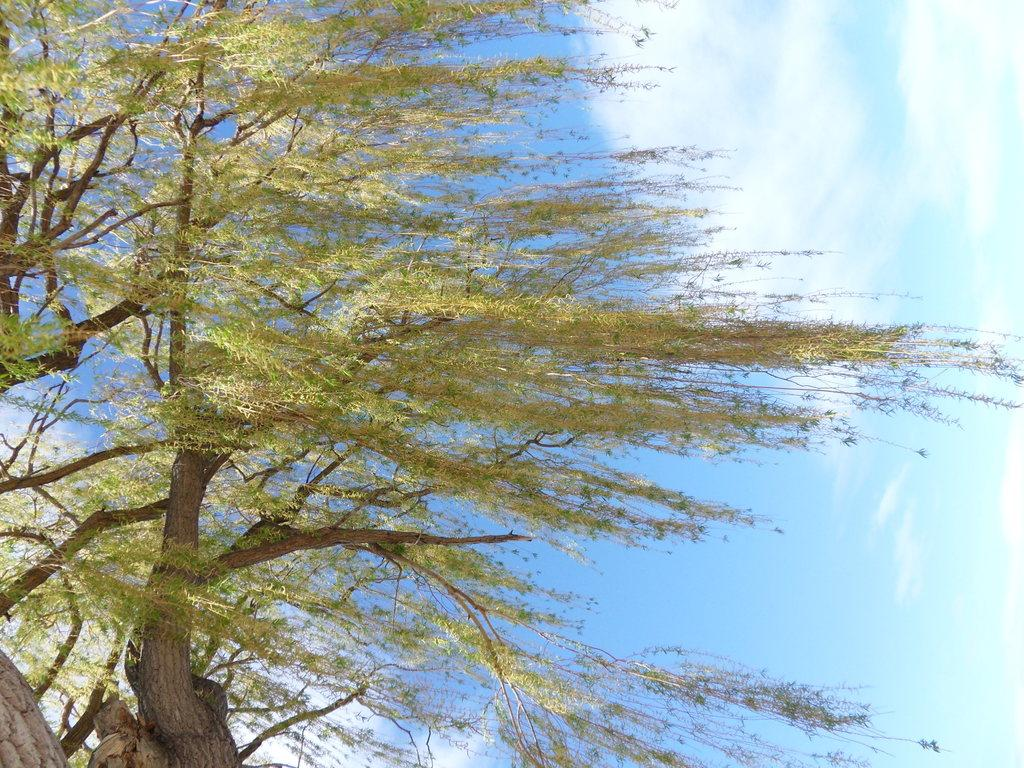What type of vegetation can be seen in the image? There are trees in the image. What is visible at the top of the image? The sky is visible at the top of the image. What can be observed in the sky? There are clouds in the sky. What type of jewel can be seen hanging from the branches of the trees in the image? There is no jewel present in the image; it only features trees and clouds in the sky. 